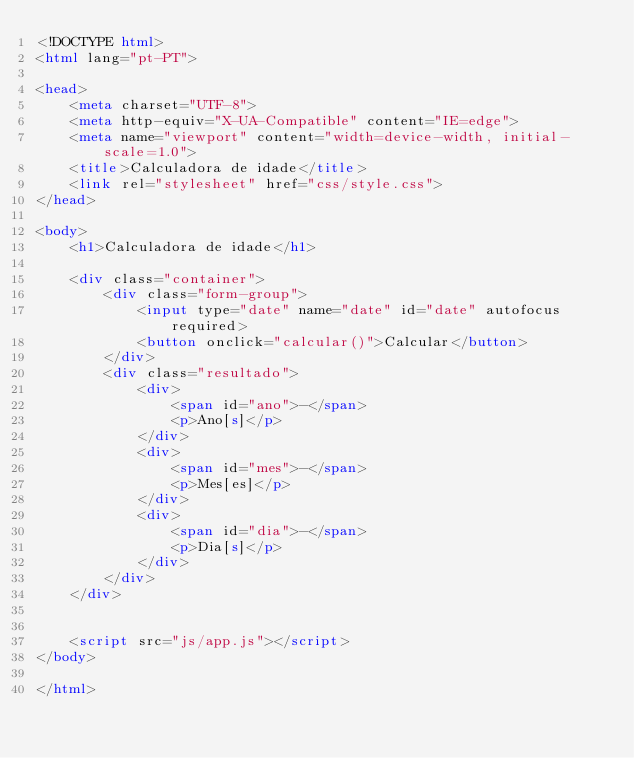<code> <loc_0><loc_0><loc_500><loc_500><_HTML_><!DOCTYPE html>
<html lang="pt-PT">

<head>
    <meta charset="UTF-8">
    <meta http-equiv="X-UA-Compatible" content="IE=edge">
    <meta name="viewport" content="width=device-width, initial-scale=1.0">
    <title>Calculadora de idade</title>
    <link rel="stylesheet" href="css/style.css">
</head>

<body>
    <h1>Calculadora de idade</h1>

    <div class="container">
        <div class="form-group">
            <input type="date" name="date" id="date" autofocus required>
            <button onclick="calcular()">Calcular</button>
        </div>
        <div class="resultado">
            <div>
                <span id="ano">-</span>
                <p>Ano[s]</p>
            </div>
            <div>
                <span id="mes">-</span>
                <p>Mes[es]</p>
            </div>
            <div>
                <span id="dia">-</span>
                <p>Dia[s]</p>
            </div>
        </div>
    </div>


    <script src="js/app.js"></script>
</body>

</html></code> 